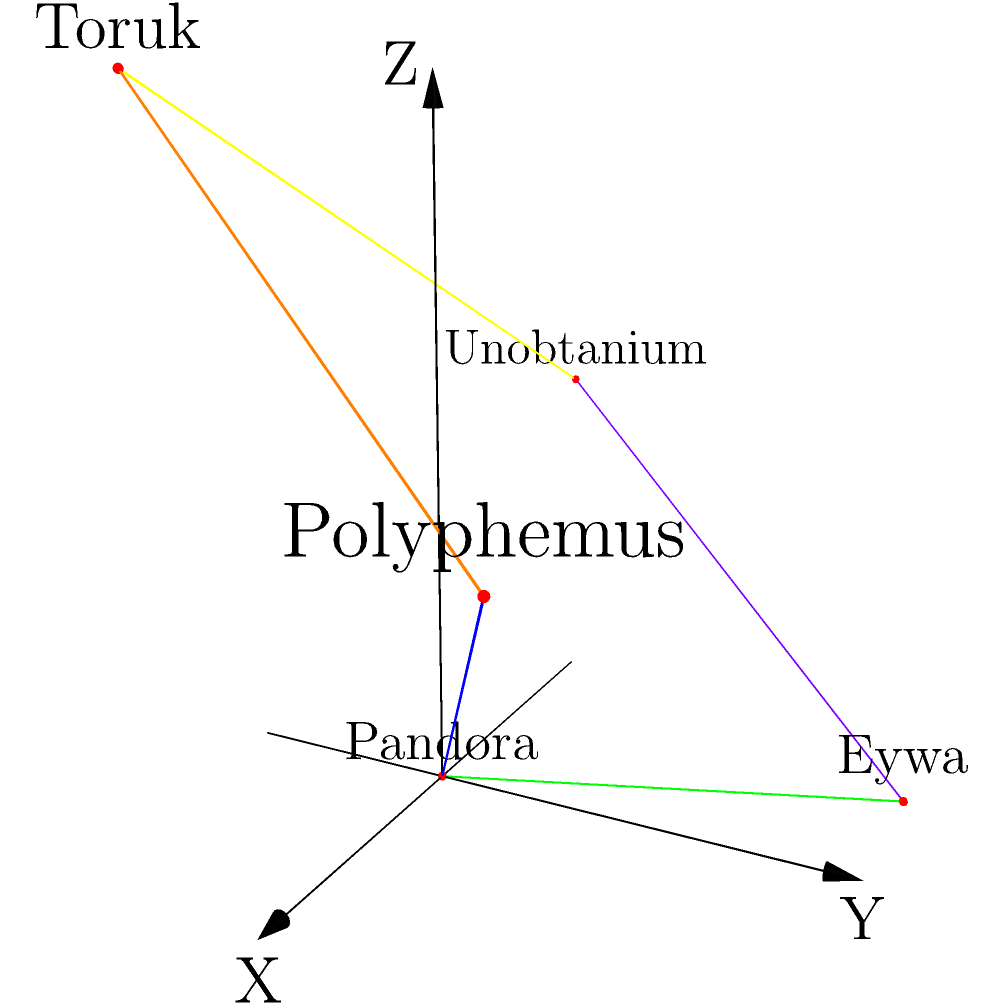In the given 3D star map of Pandoran interstellar travel routes, which star system serves as the central hub with the most direct connections to other systems? To determine the central hub in the Pandoran interstellar travel route system, we need to analyze the connections between star systems:

1. Identify all star systems:
   - Pandora
   - Polyphemus
   - Eywa
   - Toruk
   - Unobtanium

2. Count the number of direct connections for each system:
   - Pandora: 2 connections (to Polyphemus and Eywa)
   - Polyphemus: 2 connections (to Pandora and Toruk)
   - Eywa: 2 connections (to Pandora and Unobtanium)
   - Toruk: 2 connections (to Polyphemus and Unobtanium)
   - Unobtanium: 2 connections (to Eywa and Toruk)

3. Analyze the results:
   All star systems have an equal number of direct connections (2 each).

4. Consider the spatial arrangement:
   Pandora is positioned at the origin (0,0,0) of the coordinate system, suggesting it might be the reference point for the map.

5. Evaluate the strategic importance:
   As Pandora is our home planet and the origin of the coordinate system, it can be considered the central hub from a Pandoran perspective, despite having the same number of connections as other systems.

Therefore, from a Pandoran point of view, Pandora serves as the central hub in this interstellar travel route system.
Answer: Pandora 